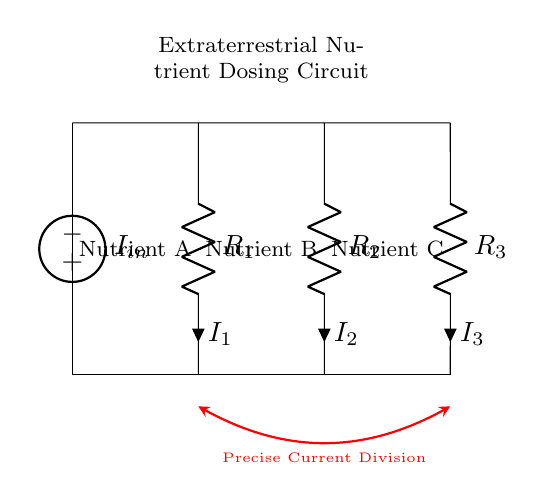What is the total current supplied to the circuit? The total current is denoted as 'I_in' in the circuit diagram, which signifies the input current flowing into the current divider configuration.
Answer: I_in What are the resistors used in the circuit? The resistors in the circuit are labeled R1, R2, and R3, each representing a different pathway for current division among the nutrients.
Answer: R1, R2, R3 How is the current divided among the resistors? The current division in a current divider circuit is determined by the resistor values: the total current splits inversely proportional to their resistances. Each resistor’s current will depend on its value relative to the total resistance of the circuit.
Answer: Inversely proportional to their resistances What is the purpose of this circuit? The purpose of the circuit is to ensure precise nutrient dosing by dividing the total current into specific paths, allowing for controlled delivery of different nutrients denoted as A, B, and C.
Answer: To ensure precise nutrient dosing Which nutrients correspond to each resistor? Nutrient A corresponds to R1, nutrient B corresponds to R2, and nutrient C corresponds to R3, as labeled in the circuit diagram.
Answer: Nutrient A, B, C What happens if one resistor fails? If one resistor fails (open circuit), the current will not flow through that path, which means the corresponding nutrient will not be delivered, impacting the medical treatment.
Answer: No delivery of that nutrient 